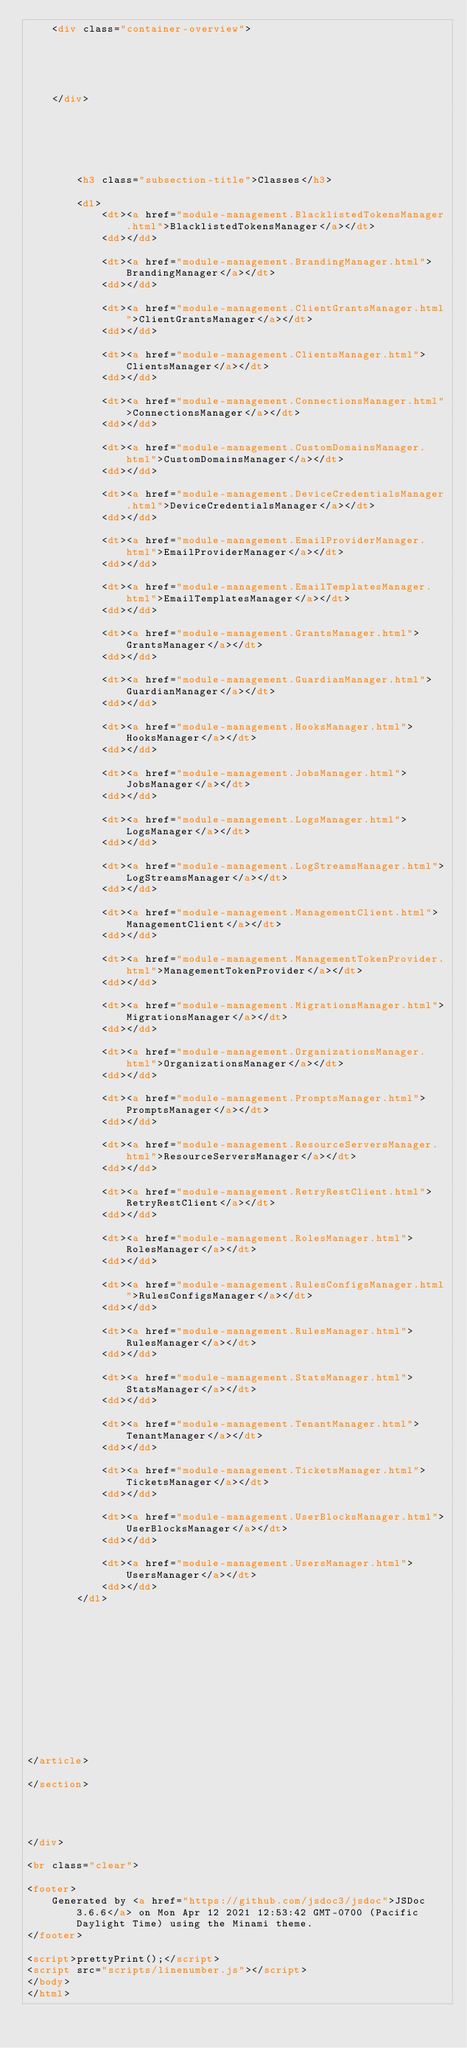Convert code to text. <code><loc_0><loc_0><loc_500><loc_500><_HTML_>    <div class="container-overview">
    
        

        
    
    </div>

    

    

    
        <h3 class="subsection-title">Classes</h3>

        <dl>
            <dt><a href="module-management.BlacklistedTokensManager.html">BlacklistedTokensManager</a></dt>
            <dd></dd>
        
            <dt><a href="module-management.BrandingManager.html">BrandingManager</a></dt>
            <dd></dd>
        
            <dt><a href="module-management.ClientGrantsManager.html">ClientGrantsManager</a></dt>
            <dd></dd>
        
            <dt><a href="module-management.ClientsManager.html">ClientsManager</a></dt>
            <dd></dd>
        
            <dt><a href="module-management.ConnectionsManager.html">ConnectionsManager</a></dt>
            <dd></dd>
        
            <dt><a href="module-management.CustomDomainsManager.html">CustomDomainsManager</a></dt>
            <dd></dd>
        
            <dt><a href="module-management.DeviceCredentialsManager.html">DeviceCredentialsManager</a></dt>
            <dd></dd>
        
            <dt><a href="module-management.EmailProviderManager.html">EmailProviderManager</a></dt>
            <dd></dd>
        
            <dt><a href="module-management.EmailTemplatesManager.html">EmailTemplatesManager</a></dt>
            <dd></dd>
        
            <dt><a href="module-management.GrantsManager.html">GrantsManager</a></dt>
            <dd></dd>
        
            <dt><a href="module-management.GuardianManager.html">GuardianManager</a></dt>
            <dd></dd>
        
            <dt><a href="module-management.HooksManager.html">HooksManager</a></dt>
            <dd></dd>
        
            <dt><a href="module-management.JobsManager.html">JobsManager</a></dt>
            <dd></dd>
        
            <dt><a href="module-management.LogsManager.html">LogsManager</a></dt>
            <dd></dd>
        
            <dt><a href="module-management.LogStreamsManager.html">LogStreamsManager</a></dt>
            <dd></dd>
        
            <dt><a href="module-management.ManagementClient.html">ManagementClient</a></dt>
            <dd></dd>
        
            <dt><a href="module-management.ManagementTokenProvider.html">ManagementTokenProvider</a></dt>
            <dd></dd>
        
            <dt><a href="module-management.MigrationsManager.html">MigrationsManager</a></dt>
            <dd></dd>
        
            <dt><a href="module-management.OrganizationsManager.html">OrganizationsManager</a></dt>
            <dd></dd>
        
            <dt><a href="module-management.PromptsManager.html">PromptsManager</a></dt>
            <dd></dd>
        
            <dt><a href="module-management.ResourceServersManager.html">ResourceServersManager</a></dt>
            <dd></dd>
        
            <dt><a href="module-management.RetryRestClient.html">RetryRestClient</a></dt>
            <dd></dd>
        
            <dt><a href="module-management.RolesManager.html">RolesManager</a></dt>
            <dd></dd>
        
            <dt><a href="module-management.RulesConfigsManager.html">RulesConfigsManager</a></dt>
            <dd></dd>
        
            <dt><a href="module-management.RulesManager.html">RulesManager</a></dt>
            <dd></dd>
        
            <dt><a href="module-management.StatsManager.html">StatsManager</a></dt>
            <dd></dd>
        
            <dt><a href="module-management.TenantManager.html">TenantManager</a></dt>
            <dd></dd>
        
            <dt><a href="module-management.TicketsManager.html">TicketsManager</a></dt>
            <dd></dd>
        
            <dt><a href="module-management.UserBlocksManager.html">UserBlocksManager</a></dt>
            <dd></dd>
        
            <dt><a href="module-management.UsersManager.html">UsersManager</a></dt>
            <dd></dd>
        </dl>
    

     

    

    

    

    

    
</article>

</section>




</div>

<br class="clear">

<footer>
    Generated by <a href="https://github.com/jsdoc3/jsdoc">JSDoc 3.6.6</a> on Mon Apr 12 2021 12:53:42 GMT-0700 (Pacific Daylight Time) using the Minami theme.
</footer>

<script>prettyPrint();</script>
<script src="scripts/linenumber.js"></script>
</body>
</html></code> 